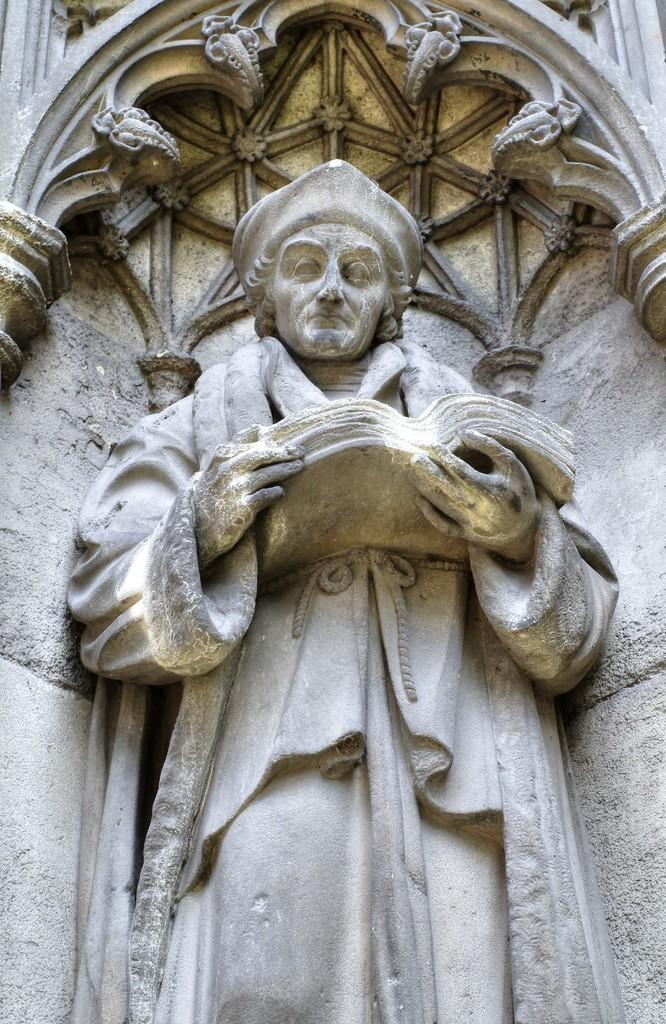What is the main subject in the image? There is a stone carved statue in the image. What is the statue holding in its hands? The statue is holding a book. What can be seen in the background of the image? There is a wall visible in the image. What type of lace can be seen decorating the church in the image? There is no church or lace present in the image; it features a stone carved statue holding a book and a wall in the background. What type of coil is wrapped around the statue in the image? There is no coil present around the statue in the image. 